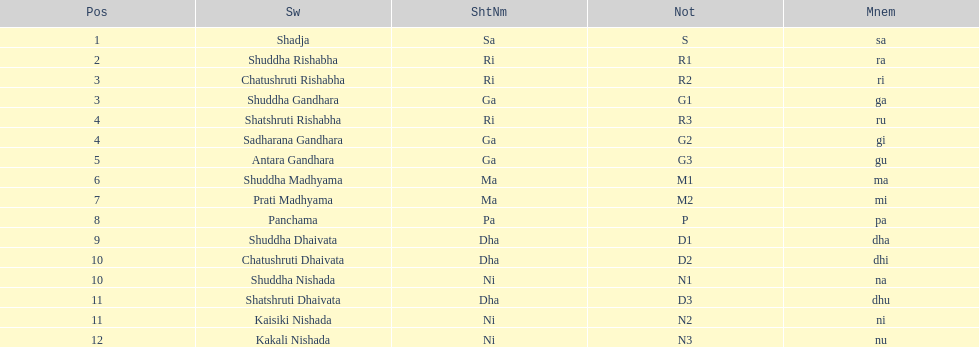Find the 9th position swara. what is its short name? Dha. 